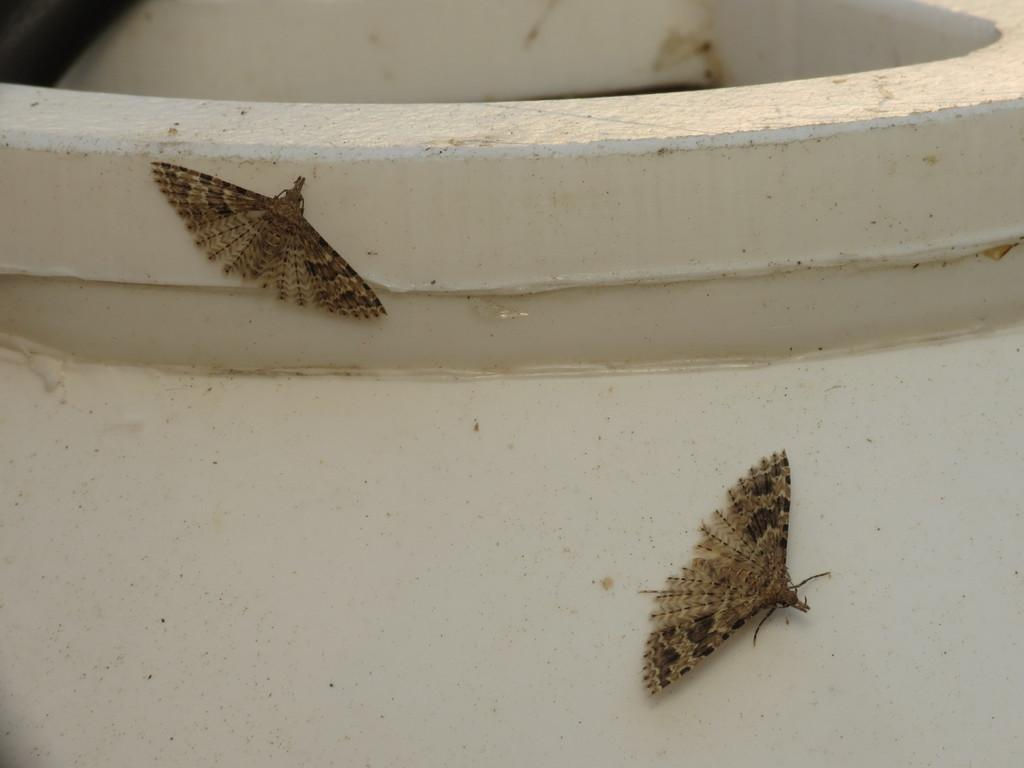What type of insects are present in the image? There are two brown house moths in the image. What are the moths resting on in the image? The moths are on a big pot. What type of flowers can be seen growing in the pot in the image? There are no flowers present in the image; it only features two brown house moths on a big pot. How many pears are visible in the image? There are no pears present in the image. 